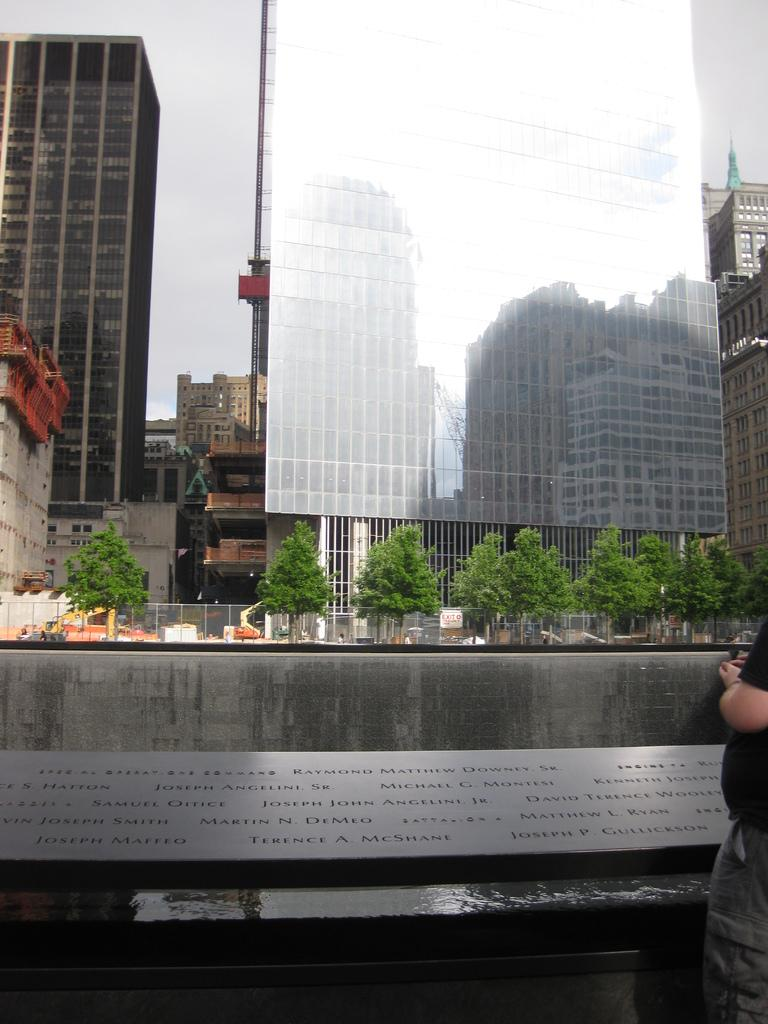What type of structures can be seen in the image? There are buildings in the image. What natural elements are present in the image? There are trees in the image. What man-made object separates the buildings and trees? There is a fence in the image. What additional information is provided by the nameplate in the image? The nameplate has names on it. Who is present in the image? There is a person in the image. What can be seen in the sky in the image? The sky is visible in the image. What type of appliance is being used by the person in the image? There is no appliance visible in the image; only the person, buildings, trees, fence, nameplate, and sky are present. What color is the chalk used by the person in the image? There is no chalk or person using chalk present in the image. 